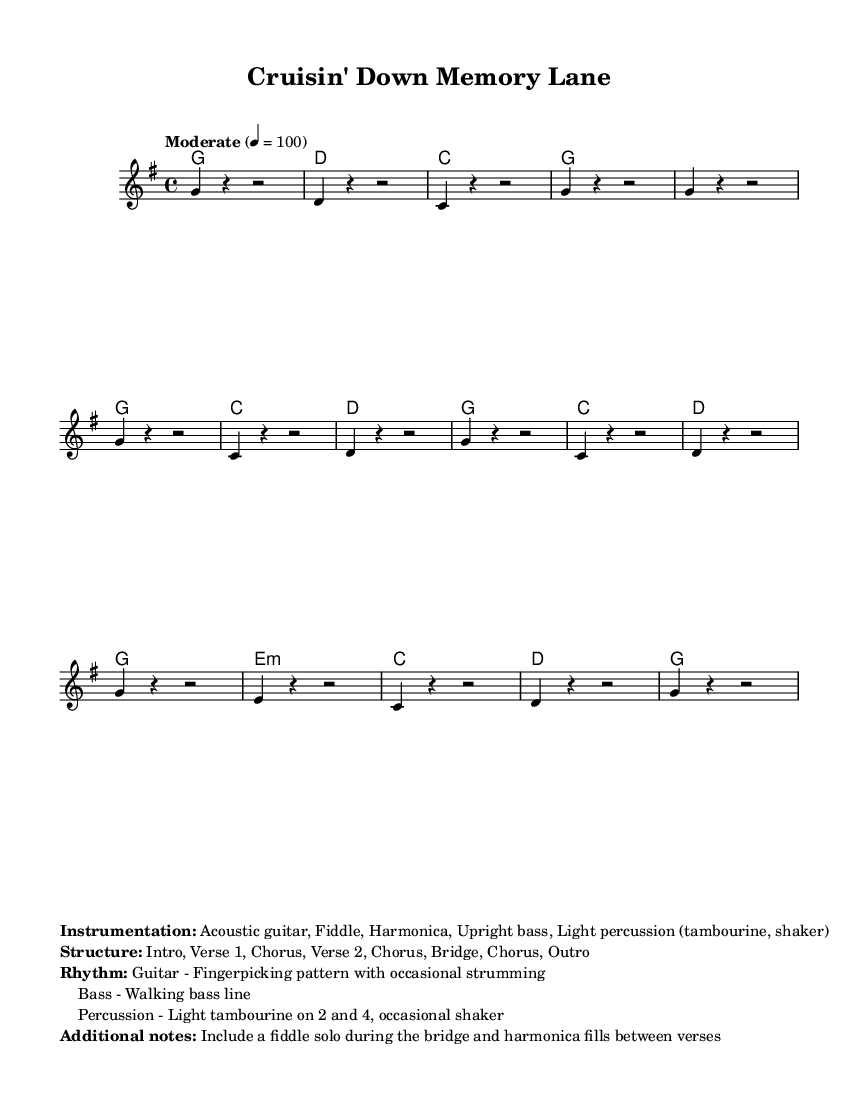What is the key signature of this music? The key signature is G major, which has one sharp (F#). This can be identified from the global section where the key is set to G major.
Answer: G major What is the time signature of this music? The time signature is 4/4, indicated in the global section as the time signature. This tells us there are four beats in each measure.
Answer: 4/4 What is the tempo of the piece? The tempo is marked as "Moderate" with a beat of 100 per minute, as shown in the global section. It indicates the speed at which the piece should be played.
Answer: 100 How many sections are in the song structure? The song structure consists of 7 sections: Intro, Verse 1, Chorus, Verse 2, Chorus, Bridge, Chorus, Outro. This is listed in the additional notes section of the markup.
Answer: 7 What type of rhythm is indicated for the guitar? The guitar rhythm is described as a fingerpicking pattern with occasional strumming. This detail is found in the additional notes section, indicating the style of guitar playing to be used.
Answer: Fingerpicking What instrument plays a solo during the bridge? The fiddle is noted to include a solo during the bridge, as mentioned in the additional notes.
Answer: Fiddle What is indicated for the bass line? The bass line is described as a walking bass line, which provides a smooth, continuous sound throughout the piece. This information also appears in the additional notes.
Answer: Walking bass line 